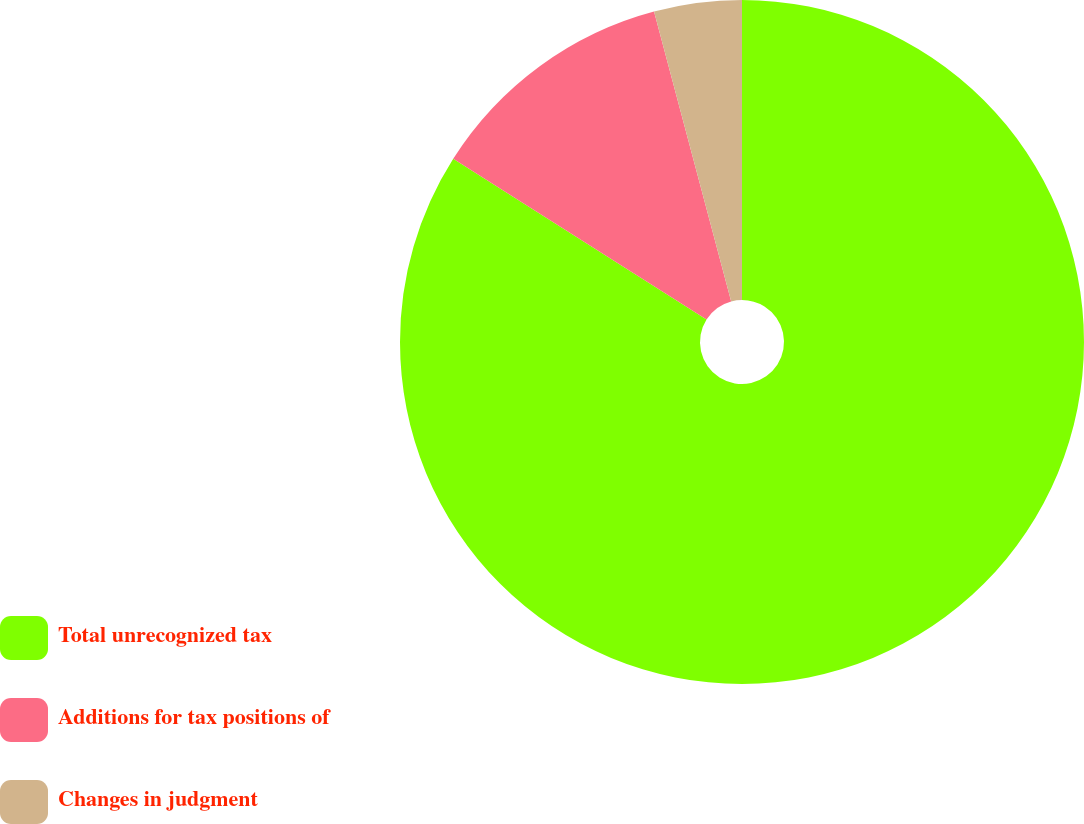<chart> <loc_0><loc_0><loc_500><loc_500><pie_chart><fcel>Total unrecognized tax<fcel>Additions for tax positions of<fcel>Changes in judgment<nl><fcel>83.99%<fcel>11.86%<fcel>4.14%<nl></chart> 